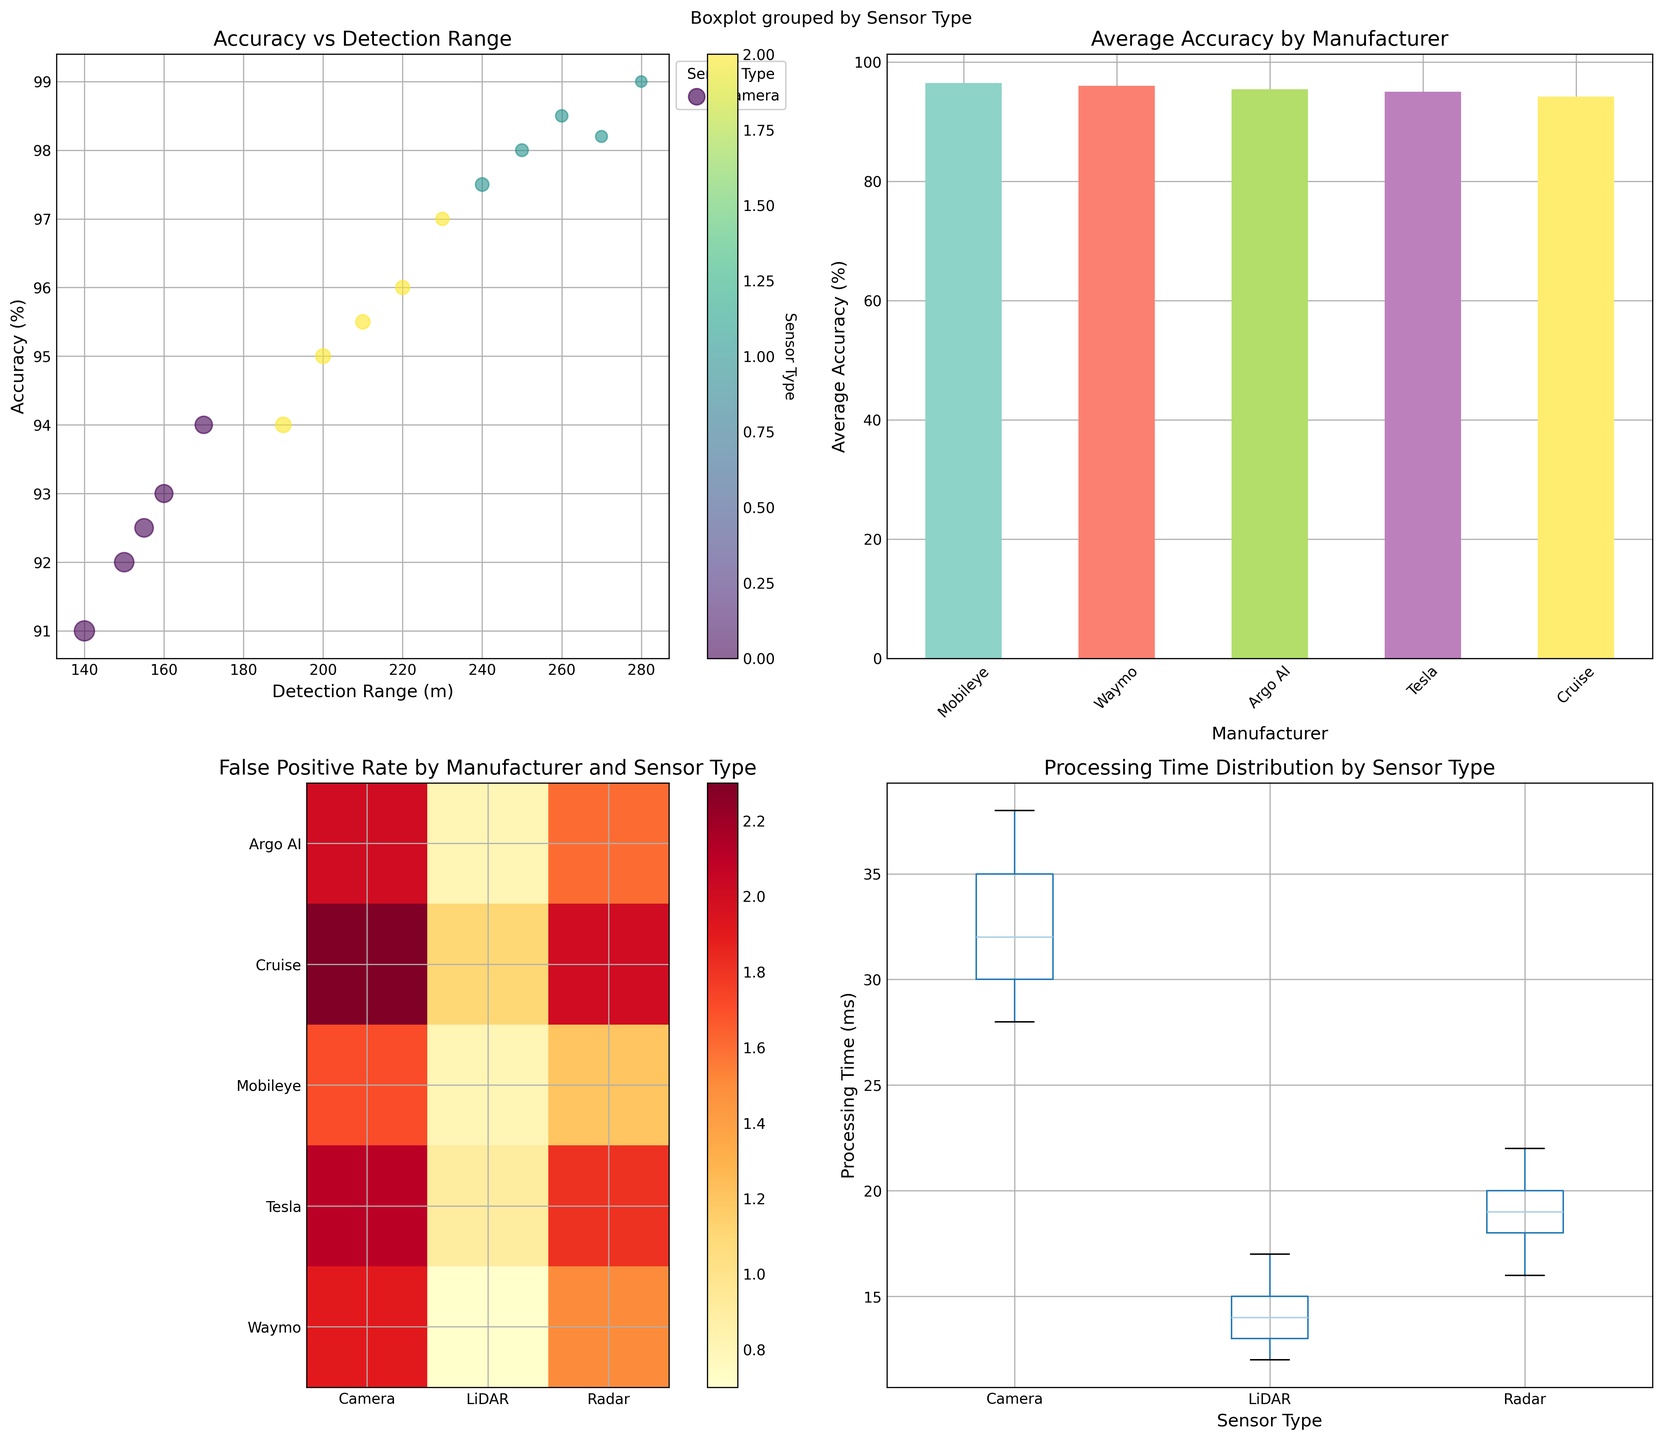What is the range of accuracy percentages for LiDAR sensors across all manufacturers? To find the range, identify the maximum and minimum accuracy percentages for LiDAR sensors. The highest accuracy is 99% (Waymo), and the lowest is 97.5% (Cruise). The range is calculated as 99% - 97.5%.
Answer: 1.5% Which manufacturer has the highest average accuracy across all sensor types? From the bar plot showing average accuracies by manufacturer, Waymo has the highest bar, indicating the highest average accuracy.
Answer: Waymo What is the False Positive Rate for Tesla's Camera sensor? Check the heatmap for the row corresponding to Tesla and the column for Camera. The value shown is 2.1%.
Answer: 2.1% Which sensor type offers the largest detection range? From the scatter plot, find the sensor type with the highest detection range on the x-axis. LiDAR sensors have the largest detection range.
Answer: LiDAR What is the median processing time for Radar sensors? From the box plot for Radar sensors in the Processing Time subplot, the median is marked by the line inside the box. The median processing time for Radar sensors falls around 18 ms.
Answer: 18 ms How much higher is Waymo's average accuracy compared to Cruise's? From the bar plot, note the average accuracy percentages for Waymo and Cruise. Waymo's average accuracy is approximately 96%, and Cruise's is 94%. The difference is 96% - 94%.
Answer: 2% Which manufacturer has the lowest average false positive rate across all sensors? By observing the heatmap for the lowest values in each row and cross-referencing those rows with the manufacturer labels, Waymo has consistently low false positive rates.
Answer: Waymo Which sensor type has the widest range of processing times? Check the box plot for each sensor type. The sensor type with the largest spread between the minimum and maximum values represents the widest range. Camera sensors show the widest range of processing times.
Answer: Camera What is the correlation trend between detection range and accuracy in the scatter plot? Observe how data points are distributed in the scatter plot: as the detection range increases (x-axis), the accuracy (y-axis) generally seems to increase.
Answer: Positive Correlation Who has the lowest detection range among the LiDAR sensors? Look at the scatter plot and identify the data point with the lowest range value within the "LiDAR" category. Cruise's LiDAR sensor has the lowest detection range at 240m.
Answer: Cruise 